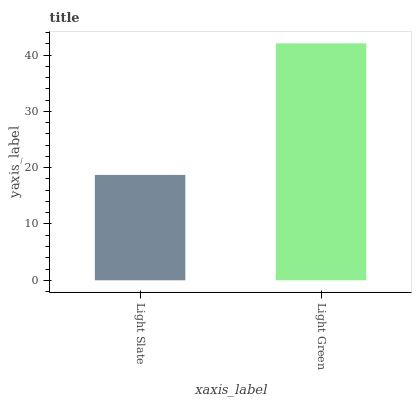Is Light Slate the minimum?
Answer yes or no. Yes. Is Light Green the maximum?
Answer yes or no. Yes. Is Light Green the minimum?
Answer yes or no. No. Is Light Green greater than Light Slate?
Answer yes or no. Yes. Is Light Slate less than Light Green?
Answer yes or no. Yes. Is Light Slate greater than Light Green?
Answer yes or no. No. Is Light Green less than Light Slate?
Answer yes or no. No. Is Light Green the high median?
Answer yes or no. Yes. Is Light Slate the low median?
Answer yes or no. Yes. Is Light Slate the high median?
Answer yes or no. No. Is Light Green the low median?
Answer yes or no. No. 